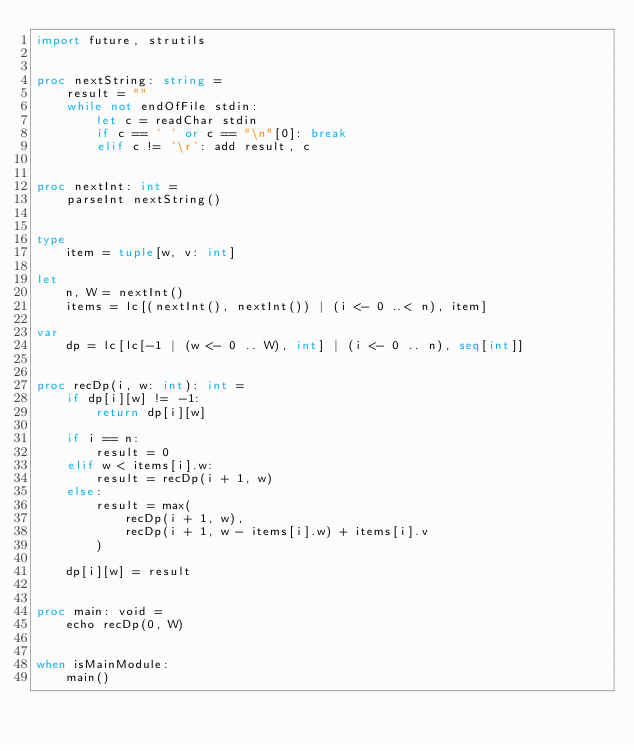Convert code to text. <code><loc_0><loc_0><loc_500><loc_500><_Nim_>import future, strutils


proc nextString: string =
    result = ""
    while not endOfFile stdin:
        let c = readChar stdin
        if c == ' ' or c == "\n"[0]: break
        elif c != '\r': add result, c


proc nextInt: int =
    parseInt nextString()


type
    item = tuple[w, v: int]

let
    n, W = nextInt()
    items = lc[(nextInt(), nextInt()) | (i <- 0 ..< n), item]

var
    dp = lc[lc[-1 | (w <- 0 .. W), int] | (i <- 0 .. n), seq[int]]


proc recDp(i, w: int): int =
    if dp[i][w] != -1:
        return dp[i][w]

    if i == n:
        result = 0
    elif w < items[i].w:
        result = recDp(i + 1, w)
    else:
        result = max(
            recDp(i + 1, w),
            recDp(i + 1, w - items[i].w) + items[i].v
        )

    dp[i][w] = result


proc main: void =
    echo recDp(0, W)


when isMainModule:
    main()
</code> 